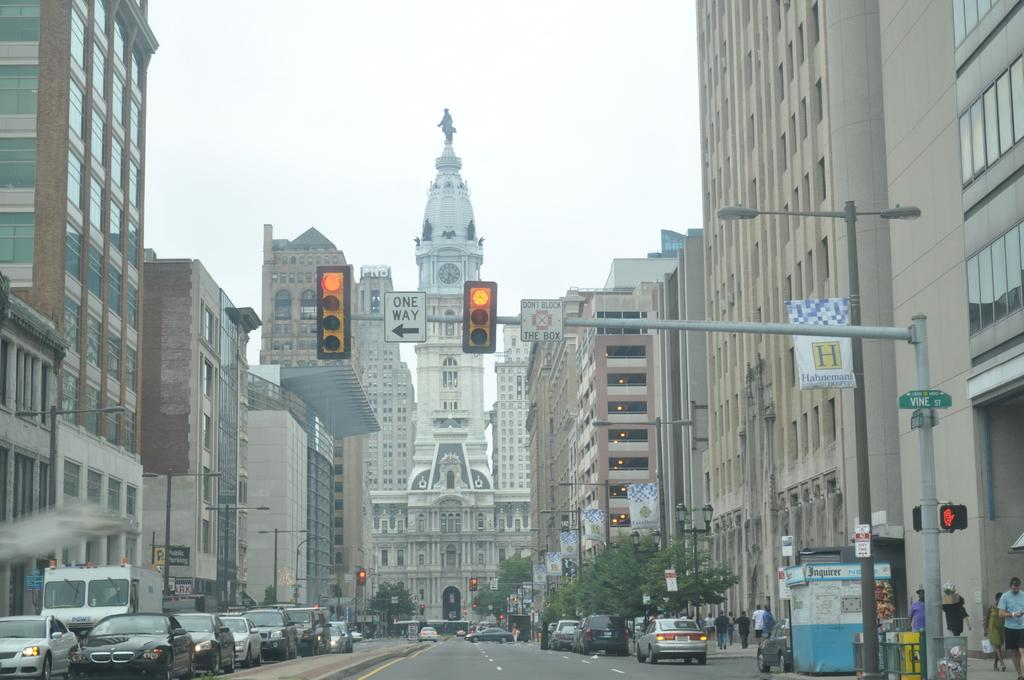<image>
Present a compact description of the photo's key features. A red light is above a street that has a green sign that says Vine St. 